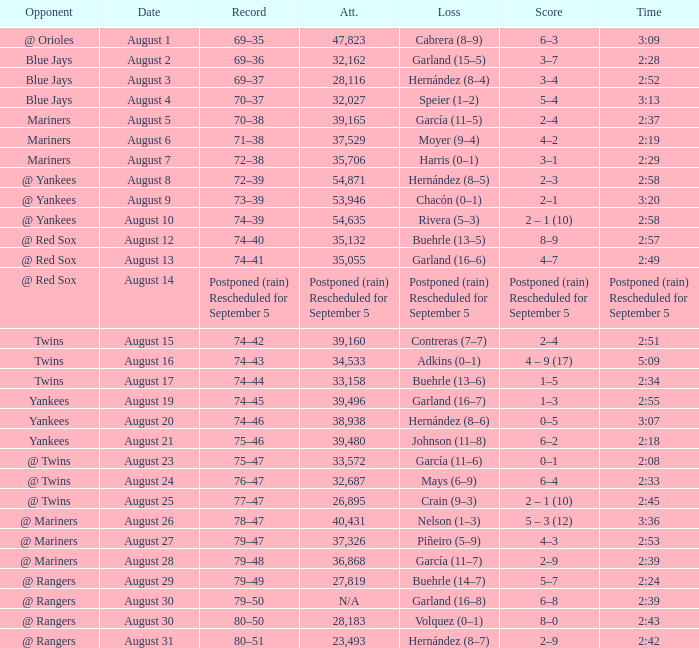Who lost on August 27? Piñeiro (5–9). 